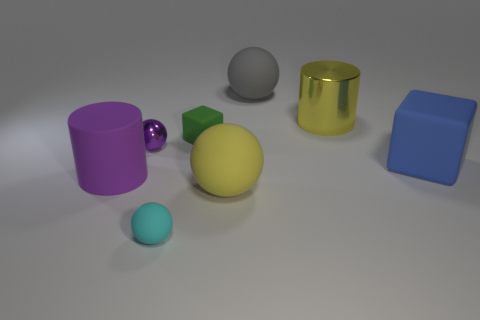Add 1 small purple shiny spheres. How many objects exist? 9 Subtract all cylinders. How many objects are left? 6 Add 4 large blocks. How many large blocks exist? 5 Subtract 0 brown blocks. How many objects are left? 8 Subtract all cylinders. Subtract all cyan rubber cubes. How many objects are left? 6 Add 8 small green cubes. How many small green cubes are left? 9 